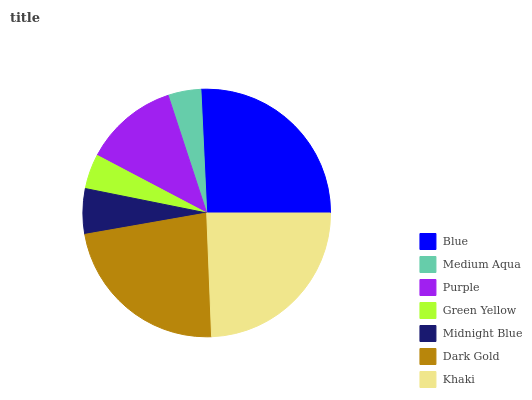Is Medium Aqua the minimum?
Answer yes or no. Yes. Is Blue the maximum?
Answer yes or no. Yes. Is Purple the minimum?
Answer yes or no. No. Is Purple the maximum?
Answer yes or no. No. Is Purple greater than Medium Aqua?
Answer yes or no. Yes. Is Medium Aqua less than Purple?
Answer yes or no. Yes. Is Medium Aqua greater than Purple?
Answer yes or no. No. Is Purple less than Medium Aqua?
Answer yes or no. No. Is Purple the high median?
Answer yes or no. Yes. Is Purple the low median?
Answer yes or no. Yes. Is Khaki the high median?
Answer yes or no. No. Is Midnight Blue the low median?
Answer yes or no. No. 